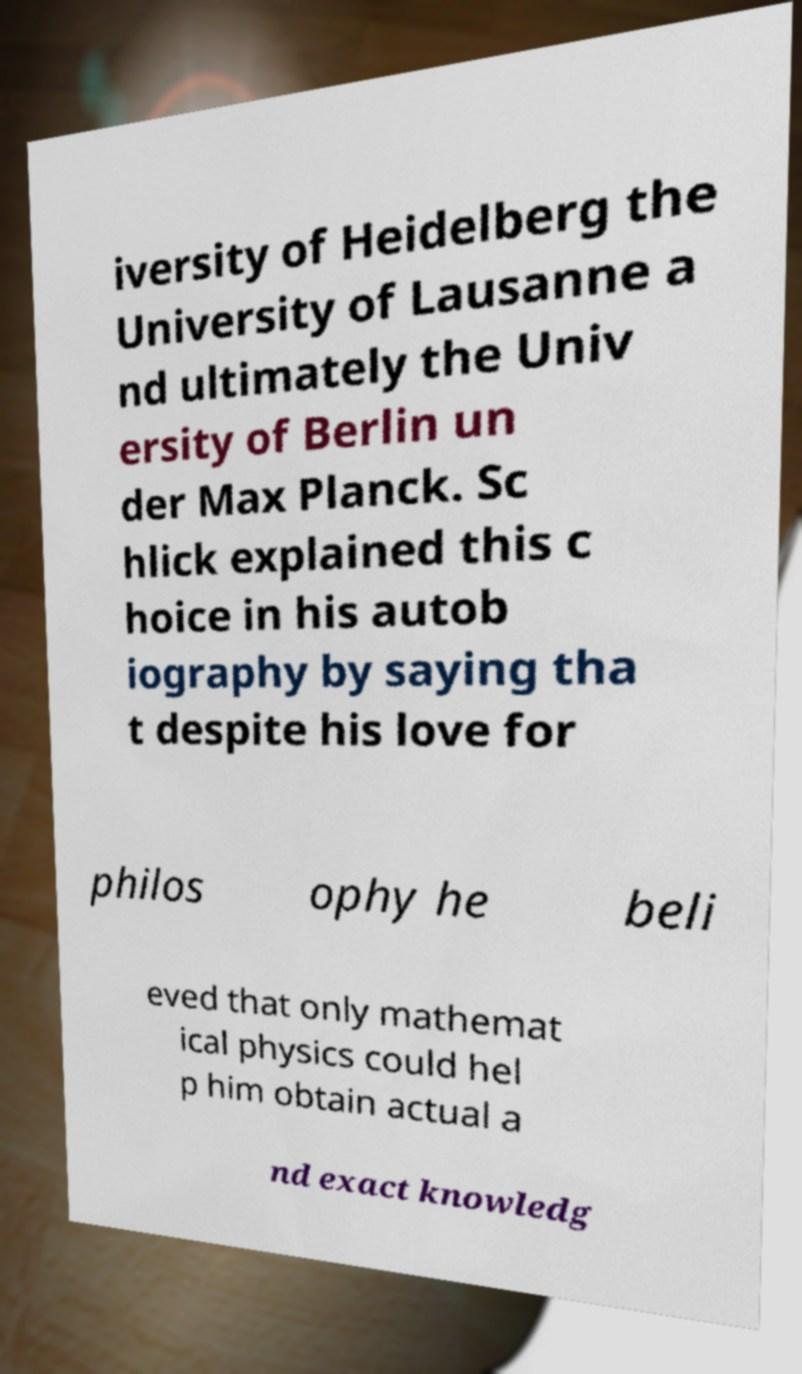Please identify and transcribe the text found in this image. iversity of Heidelberg the University of Lausanne a nd ultimately the Univ ersity of Berlin un der Max Planck. Sc hlick explained this c hoice in his autob iography by saying tha t despite his love for philos ophy he beli eved that only mathemat ical physics could hel p him obtain actual a nd exact knowledg 